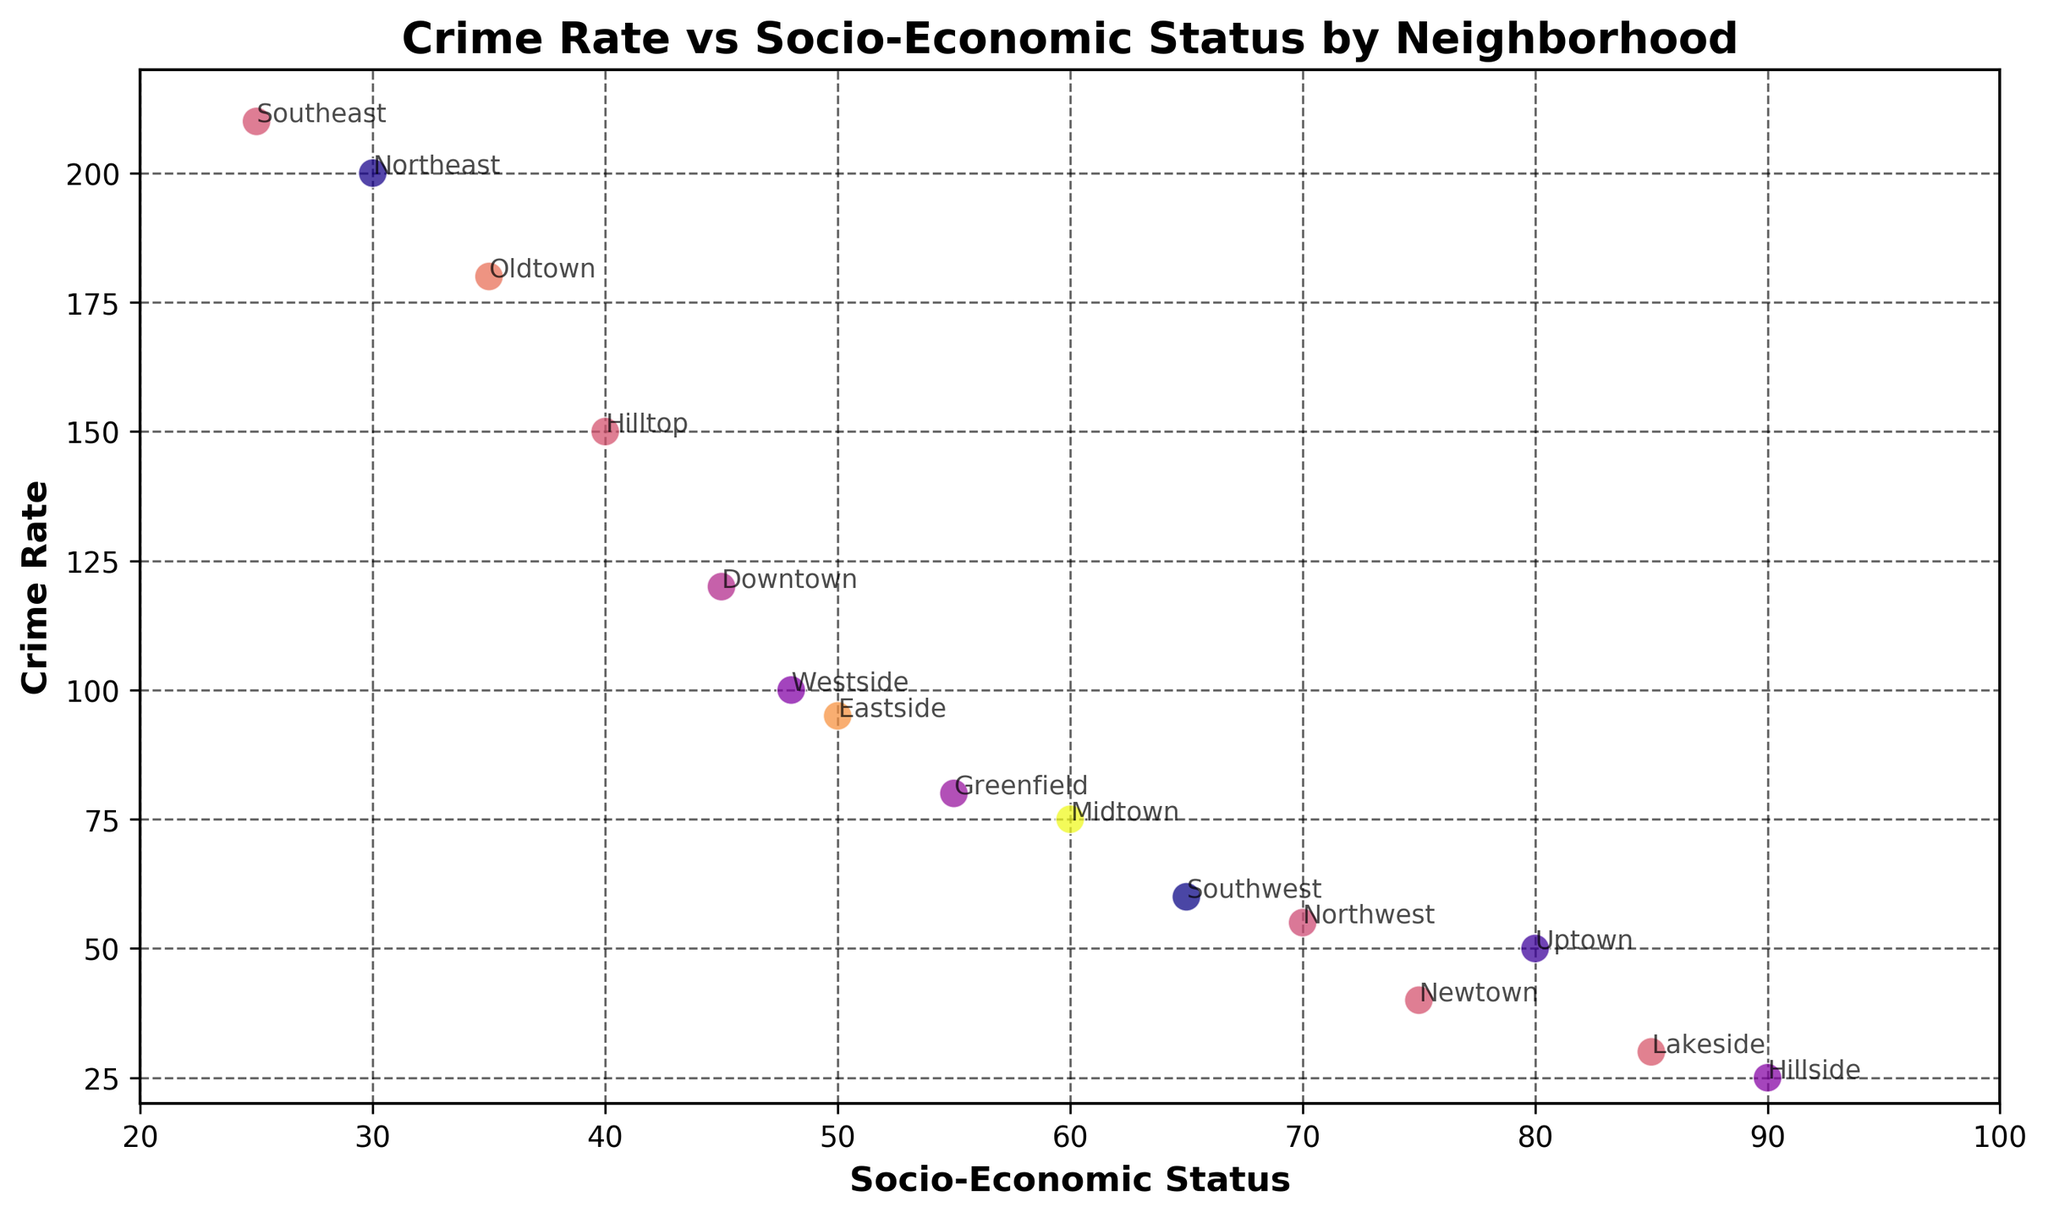What neighborhood has the highest crime rate? The scatter plot indicates the crime rate for each neighborhood by the position of the points along the vertical axis (Crime Rate). Locate the point with the highest position on this axis. Northeast is the neighborhood with the highest crime rate at 200.
Answer: Northeast How does the socio-economic status of Southwest compare to that of Southeast? Locate the points for Southwest and Southeast along the horizontal axis (Socio-Economic Status). Southwest has a socio-economic status of 65, while Southeast has a socio-economic status of 25. 65 is greater than 25.
Answer: Southwest has a higher socio-economic status than Southeast Which neighborhood with a socio-economic status above 70 has the lowest crime rate? Identify neighborhoods with socio-economic status above 70 by their horizontal positions. For these neighborhoods (Uptown, Newtown, Lakeside, Hillside), check their crime rates. The lowest crime rate in this group is Lakeside at 30.
Answer: Lakeside What is the average crime rate for neighborhoods with a socio-economic status between 40 and 60? First, find the neighborhoods within the socio-economic status range of 40 to 60: Downtown (120), Midtown (75), Eastside (95), Westside (100), Greenfield (80). Sum these crime rates: 120 + 75 + 95 + 100 + 80 = 470. Divide by the number of neighborhoods, which is 5. The average crime rate is 470/5 = 94.
Answer: 94 Compare the crime rates of Oldtown and Hilltop. Which has the higher rate and by how much? Find the points for Oldtown and Hilltop, then compare their crime rates. Oldtown's crime rate is 180, Hilltop's is 150. The difference is 180 - 150 = 30.
Answer: Oldtown has a higher crime rate by 30 Which neighborhood has a socio-economic status closest to 50? Locate the points around the socio-economic status mark of 50. The neighborhood closest to this mark is Eastside with a socio-economic status of 50 exactly.
Answer: Eastside What is the difference in crime rate between the neighborhood with the highest socio-economic status and the neighborhood with the lowest socio-economic status? Find the neighborhoods with the highest and lowest socio-economic statuses: Hillside (90) and Southeast (25), respectively. Compare their crime rates: Hillside (25) and Southeast (210). Calculate the difference: 210 - 25 = 185.
Answer: 185 How many neighborhoods have a crime rate below 50? Identify the points where the crime rate is below 50. The neighborhoods with a crime rate below 50 are Newtown, Lakeside, Hillside. Count these entries: 3 neighborhoods.
Answer: 3 